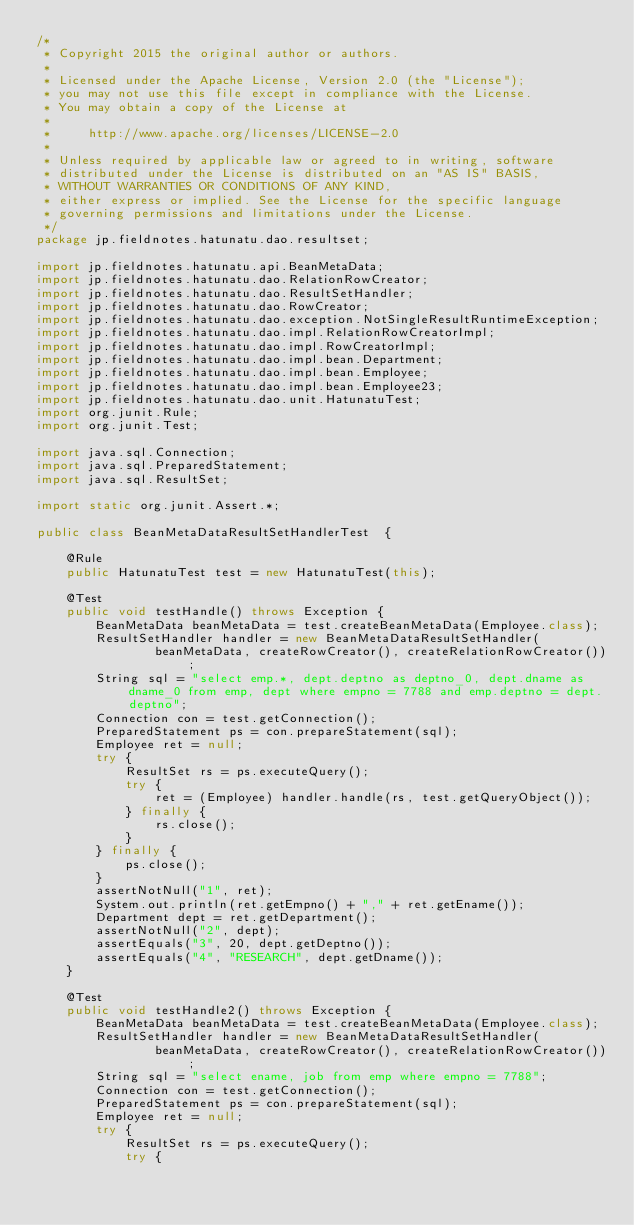<code> <loc_0><loc_0><loc_500><loc_500><_Java_>/*
 * Copyright 2015 the original author or authors.
 *
 * Licensed under the Apache License, Version 2.0 (the "License");
 * you may not use this file except in compliance with the License.
 * You may obtain a copy of the License at
 *
 *     http://www.apache.org/licenses/LICENSE-2.0
 *
 * Unless required by applicable law or agreed to in writing, software
 * distributed under the License is distributed on an "AS IS" BASIS,
 * WITHOUT WARRANTIES OR CONDITIONS OF ANY KIND,
 * either express or implied. See the License for the specific language
 * governing permissions and limitations under the License.
 */
package jp.fieldnotes.hatunatu.dao.resultset;

import jp.fieldnotes.hatunatu.api.BeanMetaData;
import jp.fieldnotes.hatunatu.dao.RelationRowCreator;
import jp.fieldnotes.hatunatu.dao.ResultSetHandler;
import jp.fieldnotes.hatunatu.dao.RowCreator;
import jp.fieldnotes.hatunatu.dao.exception.NotSingleResultRuntimeException;
import jp.fieldnotes.hatunatu.dao.impl.RelationRowCreatorImpl;
import jp.fieldnotes.hatunatu.dao.impl.RowCreatorImpl;
import jp.fieldnotes.hatunatu.dao.impl.bean.Department;
import jp.fieldnotes.hatunatu.dao.impl.bean.Employee;
import jp.fieldnotes.hatunatu.dao.impl.bean.Employee23;
import jp.fieldnotes.hatunatu.dao.unit.HatunatuTest;
import org.junit.Rule;
import org.junit.Test;

import java.sql.Connection;
import java.sql.PreparedStatement;
import java.sql.ResultSet;

import static org.junit.Assert.*;

public class BeanMetaDataResultSetHandlerTest  {

    @Rule
    public HatunatuTest test = new HatunatuTest(this);

    @Test
    public void testHandle() throws Exception {
        BeanMetaData beanMetaData = test.createBeanMetaData(Employee.class);
        ResultSetHandler handler = new BeanMetaDataResultSetHandler(
                beanMetaData, createRowCreator(), createRelationRowCreator());
        String sql = "select emp.*, dept.deptno as deptno_0, dept.dname as dname_0 from emp, dept where empno = 7788 and emp.deptno = dept.deptno";
        Connection con = test.getConnection();
        PreparedStatement ps = con.prepareStatement(sql);
        Employee ret = null;
        try {
            ResultSet rs = ps.executeQuery();
            try {
                ret = (Employee) handler.handle(rs, test.getQueryObject());
            } finally {
                rs.close();
            }
        } finally {
            ps.close();
        }
        assertNotNull("1", ret);
        System.out.println(ret.getEmpno() + "," + ret.getEname());
        Department dept = ret.getDepartment();
        assertNotNull("2", dept);
        assertEquals("3", 20, dept.getDeptno());
        assertEquals("4", "RESEARCH", dept.getDname());
    }

    @Test
    public void testHandle2() throws Exception {
        BeanMetaData beanMetaData = test.createBeanMetaData(Employee.class);
        ResultSetHandler handler = new BeanMetaDataResultSetHandler(
                beanMetaData, createRowCreator(), createRelationRowCreator());
        String sql = "select ename, job from emp where empno = 7788";
        Connection con = test.getConnection();
        PreparedStatement ps = con.prepareStatement(sql);
        Employee ret = null;
        try {
            ResultSet rs = ps.executeQuery();
            try {</code> 